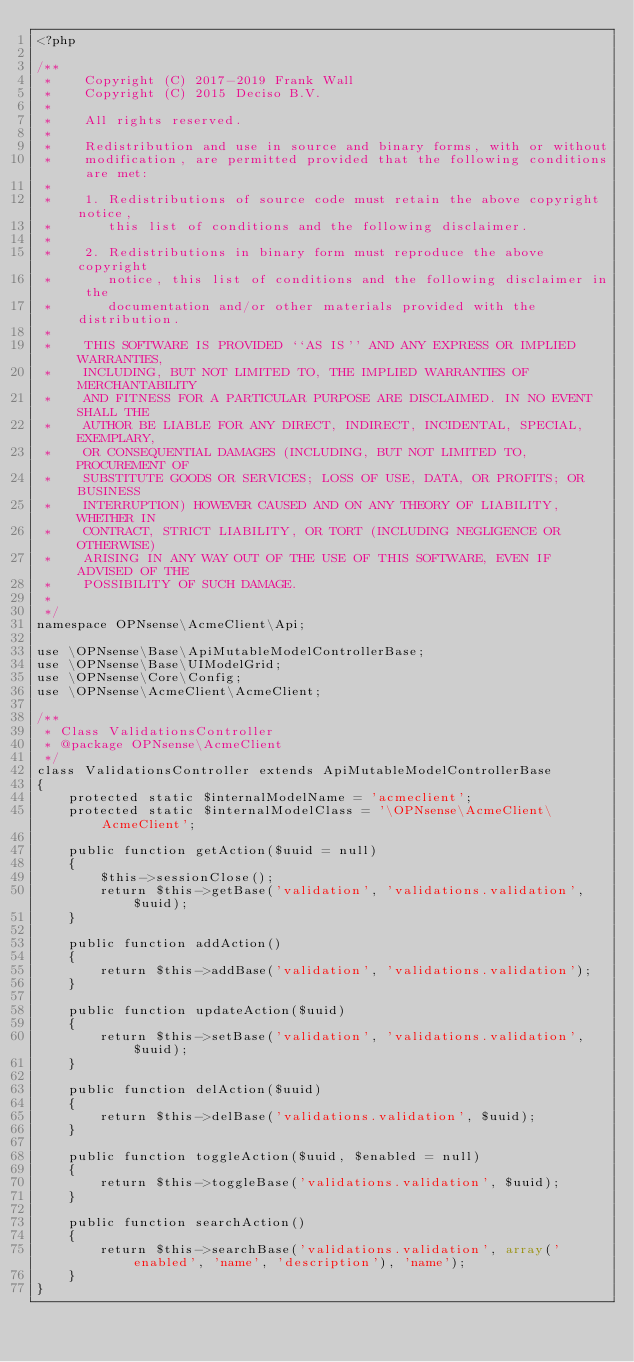<code> <loc_0><loc_0><loc_500><loc_500><_PHP_><?php

/**
 *    Copyright (C) 2017-2019 Frank Wall
 *    Copyright (C) 2015 Deciso B.V.
 *
 *    All rights reserved.
 *
 *    Redistribution and use in source and binary forms, with or without
 *    modification, are permitted provided that the following conditions are met:
 *
 *    1. Redistributions of source code must retain the above copyright notice,
 *       this list of conditions and the following disclaimer.
 *
 *    2. Redistributions in binary form must reproduce the above copyright
 *       notice, this list of conditions and the following disclaimer in the
 *       documentation and/or other materials provided with the distribution.
 *
 *    THIS SOFTWARE IS PROVIDED ``AS IS'' AND ANY EXPRESS OR IMPLIED WARRANTIES,
 *    INCLUDING, BUT NOT LIMITED TO, THE IMPLIED WARRANTIES OF MERCHANTABILITY
 *    AND FITNESS FOR A PARTICULAR PURPOSE ARE DISCLAIMED. IN NO EVENT SHALL THE
 *    AUTHOR BE LIABLE FOR ANY DIRECT, INDIRECT, INCIDENTAL, SPECIAL, EXEMPLARY,
 *    OR CONSEQUENTIAL DAMAGES (INCLUDING, BUT NOT LIMITED TO, PROCUREMENT OF
 *    SUBSTITUTE GOODS OR SERVICES; LOSS OF USE, DATA, OR PROFITS; OR BUSINESS
 *    INTERRUPTION) HOWEVER CAUSED AND ON ANY THEORY OF LIABILITY, WHETHER IN
 *    CONTRACT, STRICT LIABILITY, OR TORT (INCLUDING NEGLIGENCE OR OTHERWISE)
 *    ARISING IN ANY WAY OUT OF THE USE OF THIS SOFTWARE, EVEN IF ADVISED OF THE
 *    POSSIBILITY OF SUCH DAMAGE.
 *
 */
namespace OPNsense\AcmeClient\Api;

use \OPNsense\Base\ApiMutableModelControllerBase;
use \OPNsense\Base\UIModelGrid;
use \OPNsense\Core\Config;
use \OPNsense\AcmeClient\AcmeClient;

/**
 * Class ValidationsController
 * @package OPNsense\AcmeClient
 */
class ValidationsController extends ApiMutableModelControllerBase
{
    protected static $internalModelName = 'acmeclient';
    protected static $internalModelClass = '\OPNsense\AcmeClient\AcmeClient';

    public function getAction($uuid = null)
    {
        $this->sessionClose();
        return $this->getBase('validation', 'validations.validation', $uuid);
    }

    public function addAction()
    {
        return $this->addBase('validation', 'validations.validation');
    }

    public function updateAction($uuid)
    {
        return $this->setBase('validation', 'validations.validation', $uuid);
    }

    public function delAction($uuid)
    {
        return $this->delBase('validations.validation', $uuid);
    }

    public function toggleAction($uuid, $enabled = null)
    {
        return $this->toggleBase('validations.validation', $uuid);
    }

    public function searchAction()
    {
        return $this->searchBase('validations.validation', array('enabled', 'name', 'description'), 'name');
    }
}
</code> 